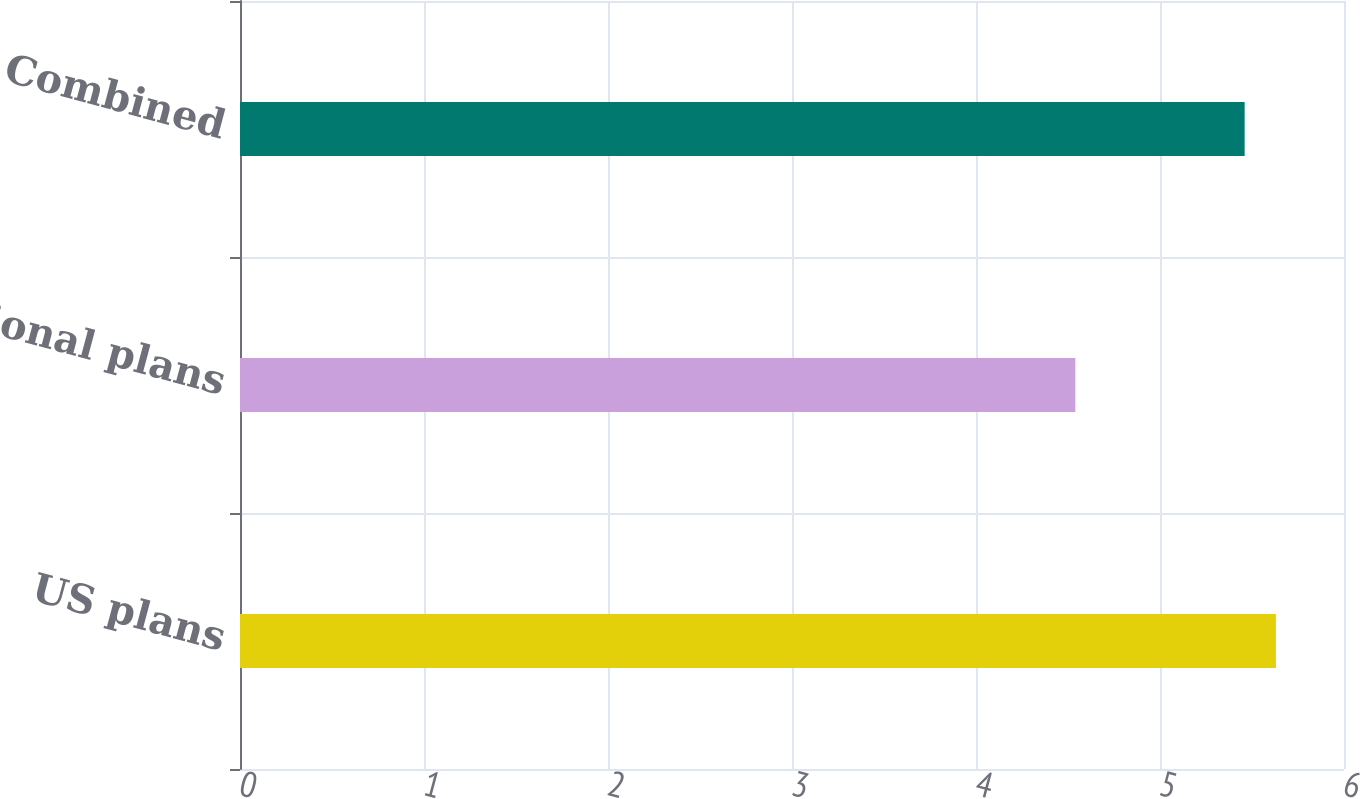Convert chart. <chart><loc_0><loc_0><loc_500><loc_500><bar_chart><fcel>US plans<fcel>International plans<fcel>Combined<nl><fcel>5.63<fcel>4.54<fcel>5.46<nl></chart> 